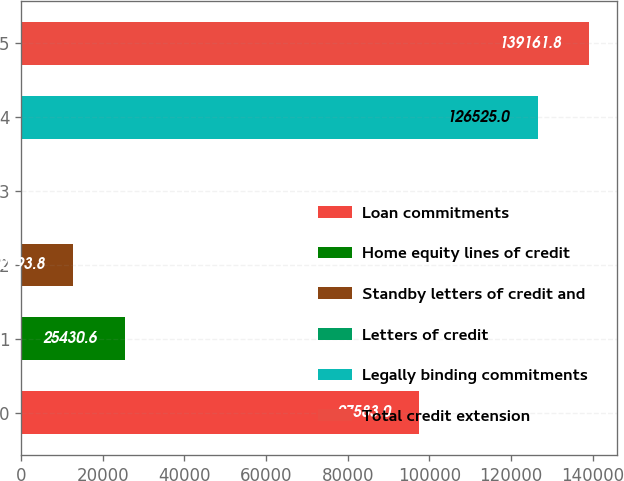Convert chart. <chart><loc_0><loc_0><loc_500><loc_500><bar_chart><fcel>Loan commitments<fcel>Home equity lines of credit<fcel>Standby letters of credit and<fcel>Letters of credit<fcel>Legally binding commitments<fcel>Total credit extension<nl><fcel>97583<fcel>25430.6<fcel>12793.8<fcel>157<fcel>126525<fcel>139162<nl></chart> 